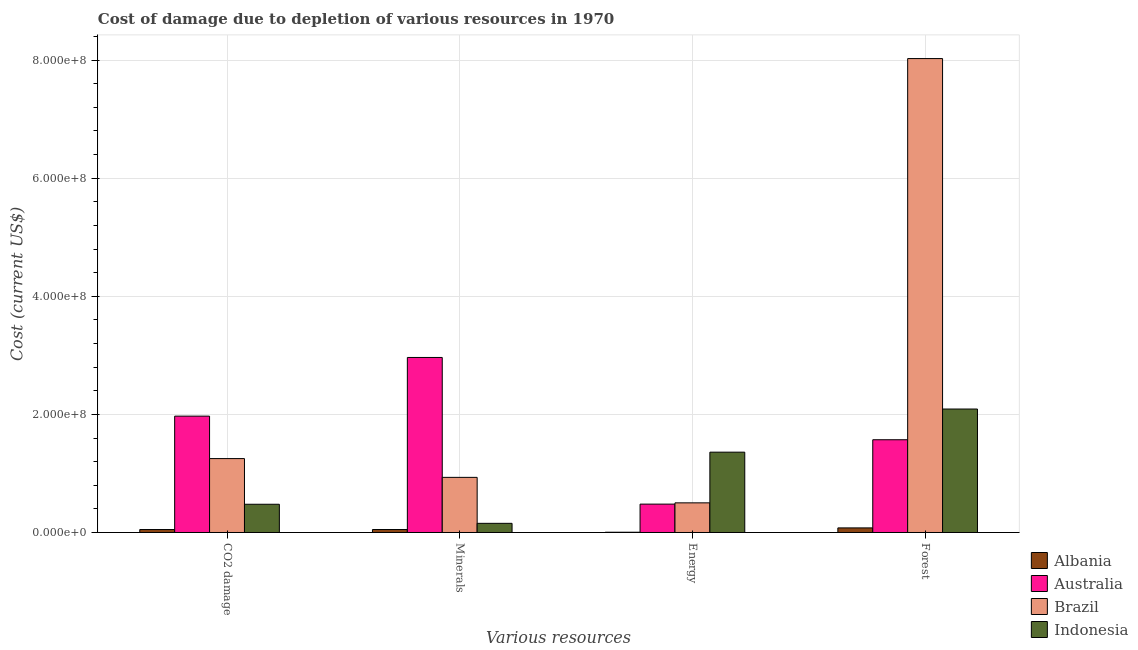How many bars are there on the 1st tick from the left?
Provide a short and direct response. 4. How many bars are there on the 2nd tick from the right?
Your answer should be compact. 4. What is the label of the 2nd group of bars from the left?
Offer a very short reply. Minerals. What is the cost of damage due to depletion of minerals in Albania?
Provide a short and direct response. 5.02e+06. Across all countries, what is the maximum cost of damage due to depletion of energy?
Ensure brevity in your answer.  1.36e+08. Across all countries, what is the minimum cost of damage due to depletion of minerals?
Your answer should be compact. 5.02e+06. In which country was the cost of damage due to depletion of coal maximum?
Provide a short and direct response. Australia. In which country was the cost of damage due to depletion of minerals minimum?
Ensure brevity in your answer.  Albania. What is the total cost of damage due to depletion of energy in the graph?
Make the answer very short. 2.35e+08. What is the difference between the cost of damage due to depletion of forests in Indonesia and that in Australia?
Ensure brevity in your answer.  5.20e+07. What is the difference between the cost of damage due to depletion of minerals in Indonesia and the cost of damage due to depletion of energy in Albania?
Your answer should be very brief. 1.51e+07. What is the average cost of damage due to depletion of minerals per country?
Your answer should be compact. 1.03e+08. What is the difference between the cost of damage due to depletion of minerals and cost of damage due to depletion of coal in Albania?
Your response must be concise. 2.17e+04. What is the ratio of the cost of damage due to depletion of energy in Australia to that in Albania?
Make the answer very short. 109.49. What is the difference between the highest and the second highest cost of damage due to depletion of coal?
Give a very brief answer. 7.19e+07. What is the difference between the highest and the lowest cost of damage due to depletion of coal?
Your response must be concise. 1.92e+08. What does the 1st bar from the left in Energy represents?
Provide a short and direct response. Albania. Is it the case that in every country, the sum of the cost of damage due to depletion of coal and cost of damage due to depletion of minerals is greater than the cost of damage due to depletion of energy?
Provide a short and direct response. No. How many bars are there?
Your answer should be compact. 16. Are all the bars in the graph horizontal?
Offer a terse response. No. How many countries are there in the graph?
Offer a very short reply. 4. Are the values on the major ticks of Y-axis written in scientific E-notation?
Offer a terse response. Yes. Does the graph contain any zero values?
Offer a terse response. No. Where does the legend appear in the graph?
Give a very brief answer. Bottom right. What is the title of the graph?
Give a very brief answer. Cost of damage due to depletion of various resources in 1970 . What is the label or title of the X-axis?
Offer a terse response. Various resources. What is the label or title of the Y-axis?
Your response must be concise. Cost (current US$). What is the Cost (current US$) in Albania in CO2 damage?
Your answer should be compact. 5.00e+06. What is the Cost (current US$) in Australia in CO2 damage?
Provide a succinct answer. 1.97e+08. What is the Cost (current US$) of Brazil in CO2 damage?
Provide a succinct answer. 1.25e+08. What is the Cost (current US$) of Indonesia in CO2 damage?
Your response must be concise. 4.78e+07. What is the Cost (current US$) of Albania in Minerals?
Offer a terse response. 5.02e+06. What is the Cost (current US$) in Australia in Minerals?
Ensure brevity in your answer.  2.96e+08. What is the Cost (current US$) of Brazil in Minerals?
Offer a very short reply. 9.33e+07. What is the Cost (current US$) of Indonesia in Minerals?
Keep it short and to the point. 1.55e+07. What is the Cost (current US$) of Albania in Energy?
Give a very brief answer. 4.39e+05. What is the Cost (current US$) of Australia in Energy?
Ensure brevity in your answer.  4.80e+07. What is the Cost (current US$) of Brazil in Energy?
Provide a short and direct response. 5.02e+07. What is the Cost (current US$) of Indonesia in Energy?
Give a very brief answer. 1.36e+08. What is the Cost (current US$) in Albania in Forest?
Provide a short and direct response. 7.78e+06. What is the Cost (current US$) in Australia in Forest?
Ensure brevity in your answer.  1.57e+08. What is the Cost (current US$) of Brazil in Forest?
Offer a very short reply. 8.03e+08. What is the Cost (current US$) of Indonesia in Forest?
Offer a terse response. 2.09e+08. Across all Various resources, what is the maximum Cost (current US$) of Albania?
Make the answer very short. 7.78e+06. Across all Various resources, what is the maximum Cost (current US$) in Australia?
Make the answer very short. 2.96e+08. Across all Various resources, what is the maximum Cost (current US$) in Brazil?
Make the answer very short. 8.03e+08. Across all Various resources, what is the maximum Cost (current US$) of Indonesia?
Provide a short and direct response. 2.09e+08. Across all Various resources, what is the minimum Cost (current US$) of Albania?
Your response must be concise. 4.39e+05. Across all Various resources, what is the minimum Cost (current US$) of Australia?
Offer a very short reply. 4.80e+07. Across all Various resources, what is the minimum Cost (current US$) of Brazil?
Offer a very short reply. 5.02e+07. Across all Various resources, what is the minimum Cost (current US$) in Indonesia?
Provide a short and direct response. 1.55e+07. What is the total Cost (current US$) of Albania in the graph?
Keep it short and to the point. 1.82e+07. What is the total Cost (current US$) in Australia in the graph?
Your answer should be compact. 6.99e+08. What is the total Cost (current US$) of Brazil in the graph?
Your answer should be very brief. 1.07e+09. What is the total Cost (current US$) of Indonesia in the graph?
Provide a short and direct response. 4.08e+08. What is the difference between the Cost (current US$) in Albania in CO2 damage and that in Minerals?
Offer a terse response. -2.17e+04. What is the difference between the Cost (current US$) in Australia in CO2 damage and that in Minerals?
Your answer should be very brief. -9.94e+07. What is the difference between the Cost (current US$) of Brazil in CO2 damage and that in Minerals?
Your answer should be compact. 3.18e+07. What is the difference between the Cost (current US$) of Indonesia in CO2 damage and that in Minerals?
Provide a succinct answer. 3.23e+07. What is the difference between the Cost (current US$) in Albania in CO2 damage and that in Energy?
Ensure brevity in your answer.  4.56e+06. What is the difference between the Cost (current US$) of Australia in CO2 damage and that in Energy?
Provide a short and direct response. 1.49e+08. What is the difference between the Cost (current US$) in Brazil in CO2 damage and that in Energy?
Provide a short and direct response. 7.50e+07. What is the difference between the Cost (current US$) of Indonesia in CO2 damage and that in Energy?
Provide a succinct answer. -8.82e+07. What is the difference between the Cost (current US$) of Albania in CO2 damage and that in Forest?
Keep it short and to the point. -2.78e+06. What is the difference between the Cost (current US$) of Australia in CO2 damage and that in Forest?
Provide a succinct answer. 4.00e+07. What is the difference between the Cost (current US$) in Brazil in CO2 damage and that in Forest?
Offer a terse response. -6.77e+08. What is the difference between the Cost (current US$) in Indonesia in CO2 damage and that in Forest?
Ensure brevity in your answer.  -1.61e+08. What is the difference between the Cost (current US$) of Albania in Minerals and that in Energy?
Ensure brevity in your answer.  4.58e+06. What is the difference between the Cost (current US$) of Australia in Minerals and that in Energy?
Provide a short and direct response. 2.48e+08. What is the difference between the Cost (current US$) of Brazil in Minerals and that in Energy?
Ensure brevity in your answer.  4.31e+07. What is the difference between the Cost (current US$) in Indonesia in Minerals and that in Energy?
Your answer should be compact. -1.21e+08. What is the difference between the Cost (current US$) in Albania in Minerals and that in Forest?
Provide a short and direct response. -2.76e+06. What is the difference between the Cost (current US$) of Australia in Minerals and that in Forest?
Offer a very short reply. 1.39e+08. What is the difference between the Cost (current US$) in Brazil in Minerals and that in Forest?
Provide a succinct answer. -7.09e+08. What is the difference between the Cost (current US$) of Indonesia in Minerals and that in Forest?
Give a very brief answer. -1.94e+08. What is the difference between the Cost (current US$) in Albania in Energy and that in Forest?
Your answer should be very brief. -7.34e+06. What is the difference between the Cost (current US$) in Australia in Energy and that in Forest?
Make the answer very short. -1.09e+08. What is the difference between the Cost (current US$) in Brazil in Energy and that in Forest?
Provide a short and direct response. -7.52e+08. What is the difference between the Cost (current US$) of Indonesia in Energy and that in Forest?
Ensure brevity in your answer.  -7.31e+07. What is the difference between the Cost (current US$) in Albania in CO2 damage and the Cost (current US$) in Australia in Minerals?
Keep it short and to the point. -2.91e+08. What is the difference between the Cost (current US$) of Albania in CO2 damage and the Cost (current US$) of Brazil in Minerals?
Provide a succinct answer. -8.83e+07. What is the difference between the Cost (current US$) in Albania in CO2 damage and the Cost (current US$) in Indonesia in Minerals?
Your answer should be compact. -1.05e+07. What is the difference between the Cost (current US$) of Australia in CO2 damage and the Cost (current US$) of Brazil in Minerals?
Your response must be concise. 1.04e+08. What is the difference between the Cost (current US$) of Australia in CO2 damage and the Cost (current US$) of Indonesia in Minerals?
Offer a terse response. 1.82e+08. What is the difference between the Cost (current US$) of Brazil in CO2 damage and the Cost (current US$) of Indonesia in Minerals?
Your answer should be very brief. 1.10e+08. What is the difference between the Cost (current US$) of Albania in CO2 damage and the Cost (current US$) of Australia in Energy?
Your answer should be compact. -4.30e+07. What is the difference between the Cost (current US$) in Albania in CO2 damage and the Cost (current US$) in Brazil in Energy?
Ensure brevity in your answer.  -4.52e+07. What is the difference between the Cost (current US$) in Albania in CO2 damage and the Cost (current US$) in Indonesia in Energy?
Your response must be concise. -1.31e+08. What is the difference between the Cost (current US$) in Australia in CO2 damage and the Cost (current US$) in Brazil in Energy?
Your answer should be very brief. 1.47e+08. What is the difference between the Cost (current US$) of Australia in CO2 damage and the Cost (current US$) of Indonesia in Energy?
Provide a short and direct response. 6.10e+07. What is the difference between the Cost (current US$) of Brazil in CO2 damage and the Cost (current US$) of Indonesia in Energy?
Your answer should be compact. -1.09e+07. What is the difference between the Cost (current US$) of Albania in CO2 damage and the Cost (current US$) of Australia in Forest?
Your response must be concise. -1.52e+08. What is the difference between the Cost (current US$) of Albania in CO2 damage and the Cost (current US$) of Brazil in Forest?
Provide a short and direct response. -7.98e+08. What is the difference between the Cost (current US$) in Albania in CO2 damage and the Cost (current US$) in Indonesia in Forest?
Offer a terse response. -2.04e+08. What is the difference between the Cost (current US$) of Australia in CO2 damage and the Cost (current US$) of Brazil in Forest?
Your answer should be very brief. -6.06e+08. What is the difference between the Cost (current US$) of Australia in CO2 damage and the Cost (current US$) of Indonesia in Forest?
Your response must be concise. -1.20e+07. What is the difference between the Cost (current US$) in Brazil in CO2 damage and the Cost (current US$) in Indonesia in Forest?
Offer a very short reply. -8.39e+07. What is the difference between the Cost (current US$) in Albania in Minerals and the Cost (current US$) in Australia in Energy?
Offer a very short reply. -4.30e+07. What is the difference between the Cost (current US$) of Albania in Minerals and the Cost (current US$) of Brazil in Energy?
Provide a succinct answer. -4.52e+07. What is the difference between the Cost (current US$) of Albania in Minerals and the Cost (current US$) of Indonesia in Energy?
Your response must be concise. -1.31e+08. What is the difference between the Cost (current US$) in Australia in Minerals and the Cost (current US$) in Brazil in Energy?
Ensure brevity in your answer.  2.46e+08. What is the difference between the Cost (current US$) in Australia in Minerals and the Cost (current US$) in Indonesia in Energy?
Provide a short and direct response. 1.60e+08. What is the difference between the Cost (current US$) in Brazil in Minerals and the Cost (current US$) in Indonesia in Energy?
Provide a succinct answer. -4.27e+07. What is the difference between the Cost (current US$) in Albania in Minerals and the Cost (current US$) in Australia in Forest?
Give a very brief answer. -1.52e+08. What is the difference between the Cost (current US$) in Albania in Minerals and the Cost (current US$) in Brazil in Forest?
Ensure brevity in your answer.  -7.98e+08. What is the difference between the Cost (current US$) of Albania in Minerals and the Cost (current US$) of Indonesia in Forest?
Your answer should be very brief. -2.04e+08. What is the difference between the Cost (current US$) in Australia in Minerals and the Cost (current US$) in Brazil in Forest?
Make the answer very short. -5.06e+08. What is the difference between the Cost (current US$) of Australia in Minerals and the Cost (current US$) of Indonesia in Forest?
Keep it short and to the point. 8.73e+07. What is the difference between the Cost (current US$) in Brazil in Minerals and the Cost (current US$) in Indonesia in Forest?
Keep it short and to the point. -1.16e+08. What is the difference between the Cost (current US$) in Albania in Energy and the Cost (current US$) in Australia in Forest?
Provide a short and direct response. -1.57e+08. What is the difference between the Cost (current US$) of Albania in Energy and the Cost (current US$) of Brazil in Forest?
Keep it short and to the point. -8.02e+08. What is the difference between the Cost (current US$) of Albania in Energy and the Cost (current US$) of Indonesia in Forest?
Your answer should be very brief. -2.09e+08. What is the difference between the Cost (current US$) in Australia in Energy and the Cost (current US$) in Brazil in Forest?
Provide a short and direct response. -7.55e+08. What is the difference between the Cost (current US$) of Australia in Energy and the Cost (current US$) of Indonesia in Forest?
Offer a terse response. -1.61e+08. What is the difference between the Cost (current US$) in Brazil in Energy and the Cost (current US$) in Indonesia in Forest?
Offer a very short reply. -1.59e+08. What is the average Cost (current US$) in Albania per Various resources?
Keep it short and to the point. 4.56e+06. What is the average Cost (current US$) in Australia per Various resources?
Provide a succinct answer. 1.75e+08. What is the average Cost (current US$) in Brazil per Various resources?
Your response must be concise. 2.68e+08. What is the average Cost (current US$) in Indonesia per Various resources?
Make the answer very short. 1.02e+08. What is the difference between the Cost (current US$) in Albania and Cost (current US$) in Australia in CO2 damage?
Provide a short and direct response. -1.92e+08. What is the difference between the Cost (current US$) of Albania and Cost (current US$) of Brazil in CO2 damage?
Provide a short and direct response. -1.20e+08. What is the difference between the Cost (current US$) of Albania and Cost (current US$) of Indonesia in CO2 damage?
Your answer should be very brief. -4.28e+07. What is the difference between the Cost (current US$) of Australia and Cost (current US$) of Brazil in CO2 damage?
Your response must be concise. 7.19e+07. What is the difference between the Cost (current US$) in Australia and Cost (current US$) in Indonesia in CO2 damage?
Provide a short and direct response. 1.49e+08. What is the difference between the Cost (current US$) in Brazil and Cost (current US$) in Indonesia in CO2 damage?
Make the answer very short. 7.73e+07. What is the difference between the Cost (current US$) of Albania and Cost (current US$) of Australia in Minerals?
Your response must be concise. -2.91e+08. What is the difference between the Cost (current US$) in Albania and Cost (current US$) in Brazil in Minerals?
Your response must be concise. -8.83e+07. What is the difference between the Cost (current US$) of Albania and Cost (current US$) of Indonesia in Minerals?
Make the answer very short. -1.05e+07. What is the difference between the Cost (current US$) of Australia and Cost (current US$) of Brazil in Minerals?
Your response must be concise. 2.03e+08. What is the difference between the Cost (current US$) of Australia and Cost (current US$) of Indonesia in Minerals?
Offer a terse response. 2.81e+08. What is the difference between the Cost (current US$) in Brazil and Cost (current US$) in Indonesia in Minerals?
Make the answer very short. 7.78e+07. What is the difference between the Cost (current US$) in Albania and Cost (current US$) in Australia in Energy?
Your answer should be compact. -4.76e+07. What is the difference between the Cost (current US$) in Albania and Cost (current US$) in Brazil in Energy?
Make the answer very short. -4.98e+07. What is the difference between the Cost (current US$) in Albania and Cost (current US$) in Indonesia in Energy?
Ensure brevity in your answer.  -1.36e+08. What is the difference between the Cost (current US$) in Australia and Cost (current US$) in Brazil in Energy?
Your answer should be very brief. -2.16e+06. What is the difference between the Cost (current US$) of Australia and Cost (current US$) of Indonesia in Energy?
Make the answer very short. -8.80e+07. What is the difference between the Cost (current US$) in Brazil and Cost (current US$) in Indonesia in Energy?
Offer a terse response. -8.58e+07. What is the difference between the Cost (current US$) of Albania and Cost (current US$) of Australia in Forest?
Offer a very short reply. -1.49e+08. What is the difference between the Cost (current US$) of Albania and Cost (current US$) of Brazil in Forest?
Offer a very short reply. -7.95e+08. What is the difference between the Cost (current US$) in Albania and Cost (current US$) in Indonesia in Forest?
Keep it short and to the point. -2.01e+08. What is the difference between the Cost (current US$) in Australia and Cost (current US$) in Brazil in Forest?
Provide a succinct answer. -6.46e+08. What is the difference between the Cost (current US$) of Australia and Cost (current US$) of Indonesia in Forest?
Keep it short and to the point. -5.20e+07. What is the difference between the Cost (current US$) of Brazil and Cost (current US$) of Indonesia in Forest?
Your answer should be very brief. 5.93e+08. What is the ratio of the Cost (current US$) of Australia in CO2 damage to that in Minerals?
Keep it short and to the point. 0.66. What is the ratio of the Cost (current US$) in Brazil in CO2 damage to that in Minerals?
Your answer should be very brief. 1.34. What is the ratio of the Cost (current US$) in Indonesia in CO2 damage to that in Minerals?
Your response must be concise. 3.08. What is the ratio of the Cost (current US$) in Albania in CO2 damage to that in Energy?
Offer a very short reply. 11.39. What is the ratio of the Cost (current US$) in Australia in CO2 damage to that in Energy?
Offer a terse response. 4.1. What is the ratio of the Cost (current US$) of Brazil in CO2 damage to that in Energy?
Provide a succinct answer. 2.49. What is the ratio of the Cost (current US$) in Indonesia in CO2 damage to that in Energy?
Make the answer very short. 0.35. What is the ratio of the Cost (current US$) in Albania in CO2 damage to that in Forest?
Make the answer very short. 0.64. What is the ratio of the Cost (current US$) in Australia in CO2 damage to that in Forest?
Provide a short and direct response. 1.25. What is the ratio of the Cost (current US$) of Brazil in CO2 damage to that in Forest?
Make the answer very short. 0.16. What is the ratio of the Cost (current US$) in Indonesia in CO2 damage to that in Forest?
Your answer should be compact. 0.23. What is the ratio of the Cost (current US$) of Albania in Minerals to that in Energy?
Offer a very short reply. 11.44. What is the ratio of the Cost (current US$) of Australia in Minerals to that in Energy?
Your answer should be very brief. 6.17. What is the ratio of the Cost (current US$) of Brazil in Minerals to that in Energy?
Offer a very short reply. 1.86. What is the ratio of the Cost (current US$) of Indonesia in Minerals to that in Energy?
Your answer should be compact. 0.11. What is the ratio of the Cost (current US$) in Albania in Minerals to that in Forest?
Your response must be concise. 0.65. What is the ratio of the Cost (current US$) of Australia in Minerals to that in Forest?
Make the answer very short. 1.89. What is the ratio of the Cost (current US$) in Brazil in Minerals to that in Forest?
Keep it short and to the point. 0.12. What is the ratio of the Cost (current US$) in Indonesia in Minerals to that in Forest?
Your response must be concise. 0.07. What is the ratio of the Cost (current US$) in Albania in Energy to that in Forest?
Offer a terse response. 0.06. What is the ratio of the Cost (current US$) of Australia in Energy to that in Forest?
Your response must be concise. 0.31. What is the ratio of the Cost (current US$) of Brazil in Energy to that in Forest?
Ensure brevity in your answer.  0.06. What is the ratio of the Cost (current US$) in Indonesia in Energy to that in Forest?
Provide a short and direct response. 0.65. What is the difference between the highest and the second highest Cost (current US$) in Albania?
Provide a short and direct response. 2.76e+06. What is the difference between the highest and the second highest Cost (current US$) in Australia?
Keep it short and to the point. 9.94e+07. What is the difference between the highest and the second highest Cost (current US$) of Brazil?
Make the answer very short. 6.77e+08. What is the difference between the highest and the second highest Cost (current US$) in Indonesia?
Provide a succinct answer. 7.31e+07. What is the difference between the highest and the lowest Cost (current US$) in Albania?
Make the answer very short. 7.34e+06. What is the difference between the highest and the lowest Cost (current US$) of Australia?
Make the answer very short. 2.48e+08. What is the difference between the highest and the lowest Cost (current US$) in Brazil?
Offer a very short reply. 7.52e+08. What is the difference between the highest and the lowest Cost (current US$) of Indonesia?
Provide a short and direct response. 1.94e+08. 